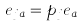Convert formula to latex. <formula><loc_0><loc_0><loc_500><loc_500>e _ { j a } = p _ { j } e _ { a }</formula> 